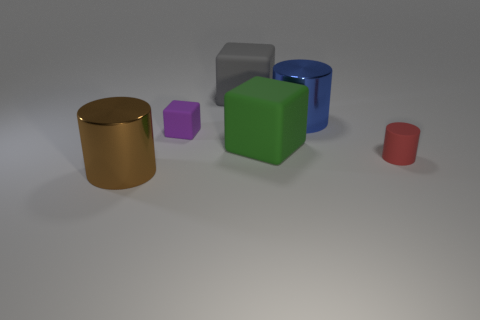How many large shiny cylinders are to the right of the tiny rubber cube and in front of the green thing?
Provide a short and direct response. 0. What number of things are either small rubber objects that are on the right side of the green rubber object or metal cylinders that are to the left of the small matte block?
Provide a succinct answer. 2. How many other objects are the same shape as the gray thing?
Your answer should be very brief. 2. There is a big cylinder that is in front of the large blue metallic thing; is its color the same as the rubber cylinder?
Your answer should be compact. No. What number of other objects are there of the same size as the red thing?
Your answer should be very brief. 1. Are the purple thing and the red cylinder made of the same material?
Provide a short and direct response. Yes. The large matte object that is in front of the large shiny cylinder that is behind the red cylinder is what color?
Ensure brevity in your answer.  Green. What is the size of the red rubber thing that is the same shape as the big brown thing?
Provide a short and direct response. Small. Do the matte cylinder and the tiny block have the same color?
Your answer should be very brief. No. How many rubber objects are in front of the metallic thing that is to the right of the cylinder in front of the tiny red rubber thing?
Offer a very short reply. 3. 